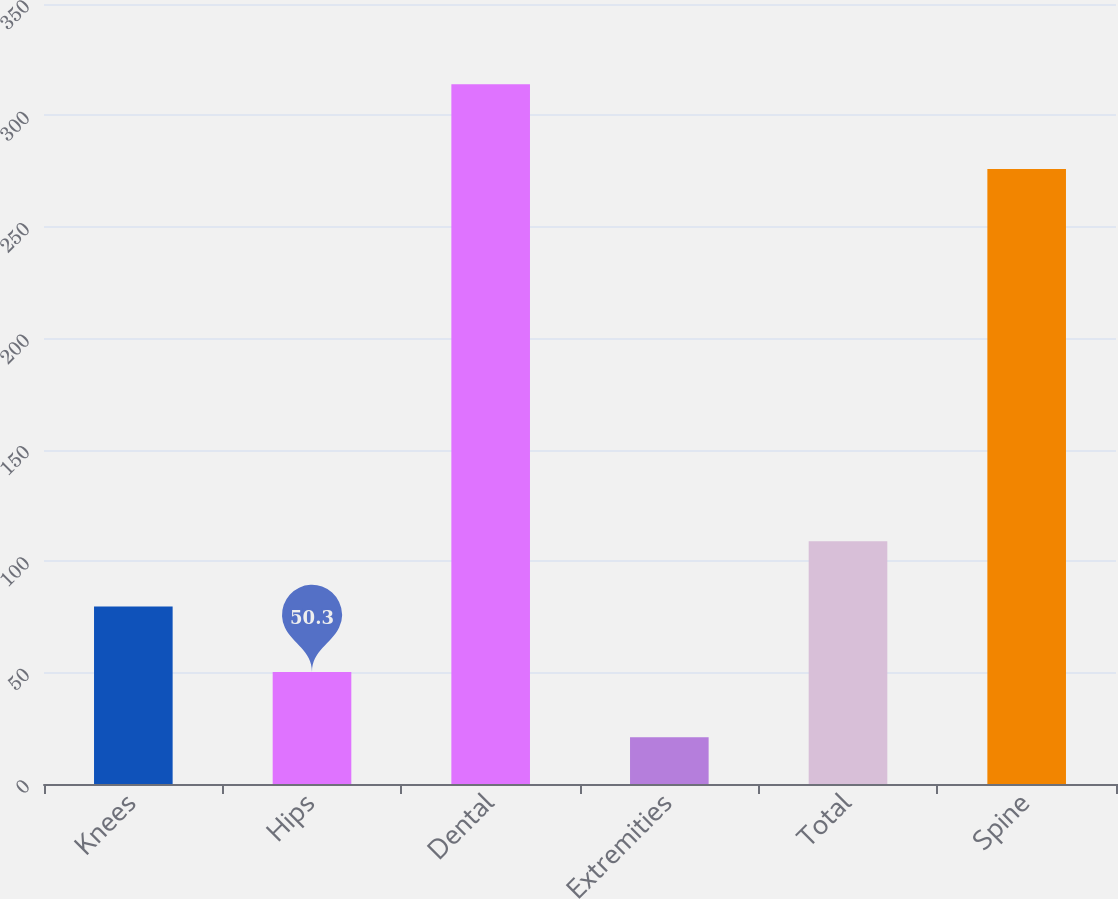Convert chart. <chart><loc_0><loc_0><loc_500><loc_500><bar_chart><fcel>Knees<fcel>Hips<fcel>Dental<fcel>Extremities<fcel>Total<fcel>Spine<nl><fcel>79.6<fcel>50.3<fcel>314<fcel>21<fcel>108.9<fcel>276<nl></chart> 